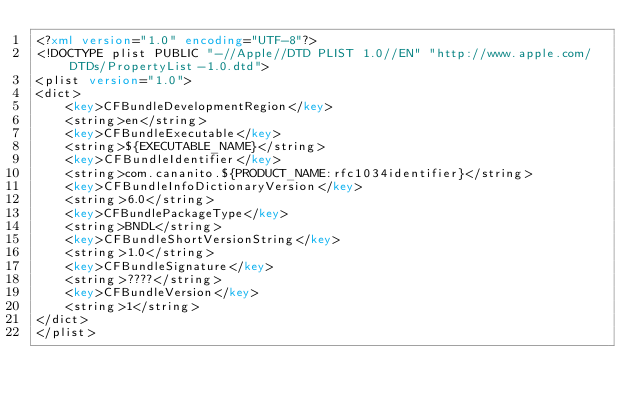<code> <loc_0><loc_0><loc_500><loc_500><_XML_><?xml version="1.0" encoding="UTF-8"?>
<!DOCTYPE plist PUBLIC "-//Apple//DTD PLIST 1.0//EN" "http://www.apple.com/DTDs/PropertyList-1.0.dtd">
<plist version="1.0">
<dict>
	<key>CFBundleDevelopmentRegion</key>
	<string>en</string>
	<key>CFBundleExecutable</key>
	<string>${EXECUTABLE_NAME}</string>
	<key>CFBundleIdentifier</key>
	<string>com.cananito.${PRODUCT_NAME:rfc1034identifier}</string>
	<key>CFBundleInfoDictionaryVersion</key>
	<string>6.0</string>
	<key>CFBundlePackageType</key>
	<string>BNDL</string>
	<key>CFBundleShortVersionString</key>
	<string>1.0</string>
	<key>CFBundleSignature</key>
	<string>????</string>
	<key>CFBundleVersion</key>
	<string>1</string>
</dict>
</plist>
</code> 